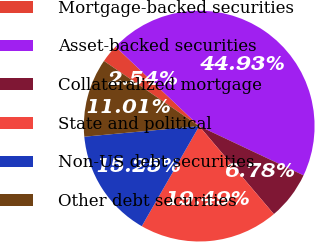<chart> <loc_0><loc_0><loc_500><loc_500><pie_chart><fcel>Mortgage-backed securities<fcel>Asset-backed securities<fcel>Collateralized mortgage<fcel>State and political<fcel>Non-US debt securities<fcel>Other debt securities<nl><fcel>2.54%<fcel>44.93%<fcel>6.78%<fcel>19.49%<fcel>15.25%<fcel>11.01%<nl></chart> 